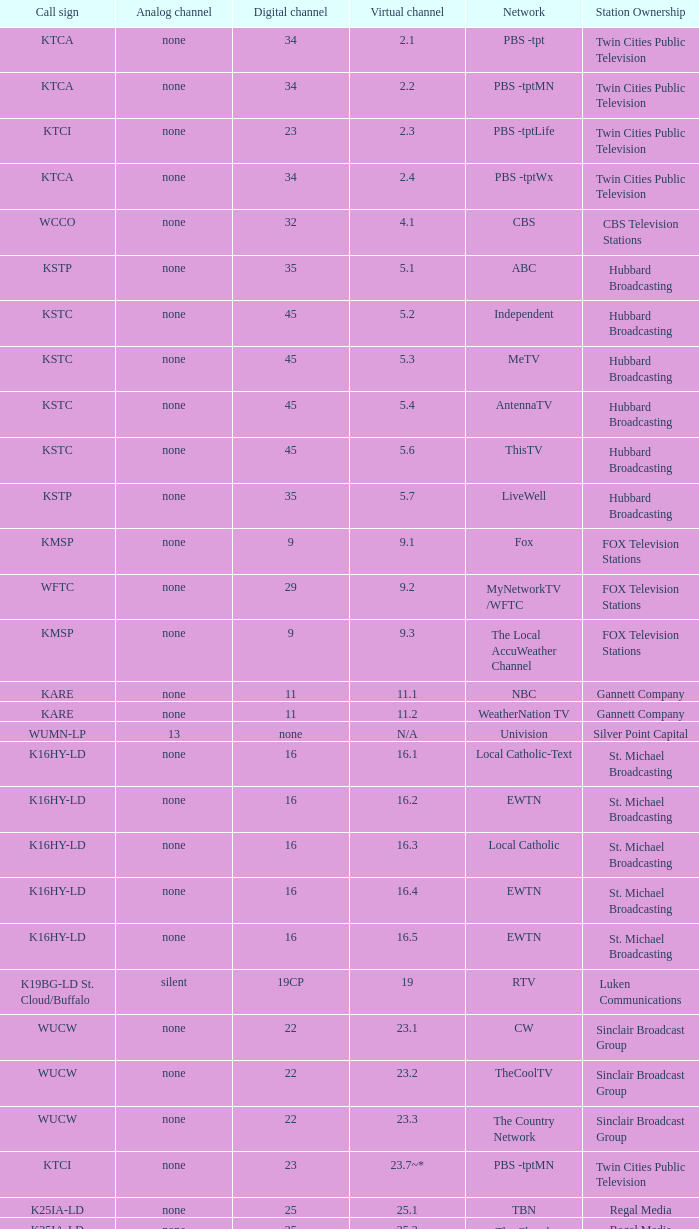5? K16HY-LD. 